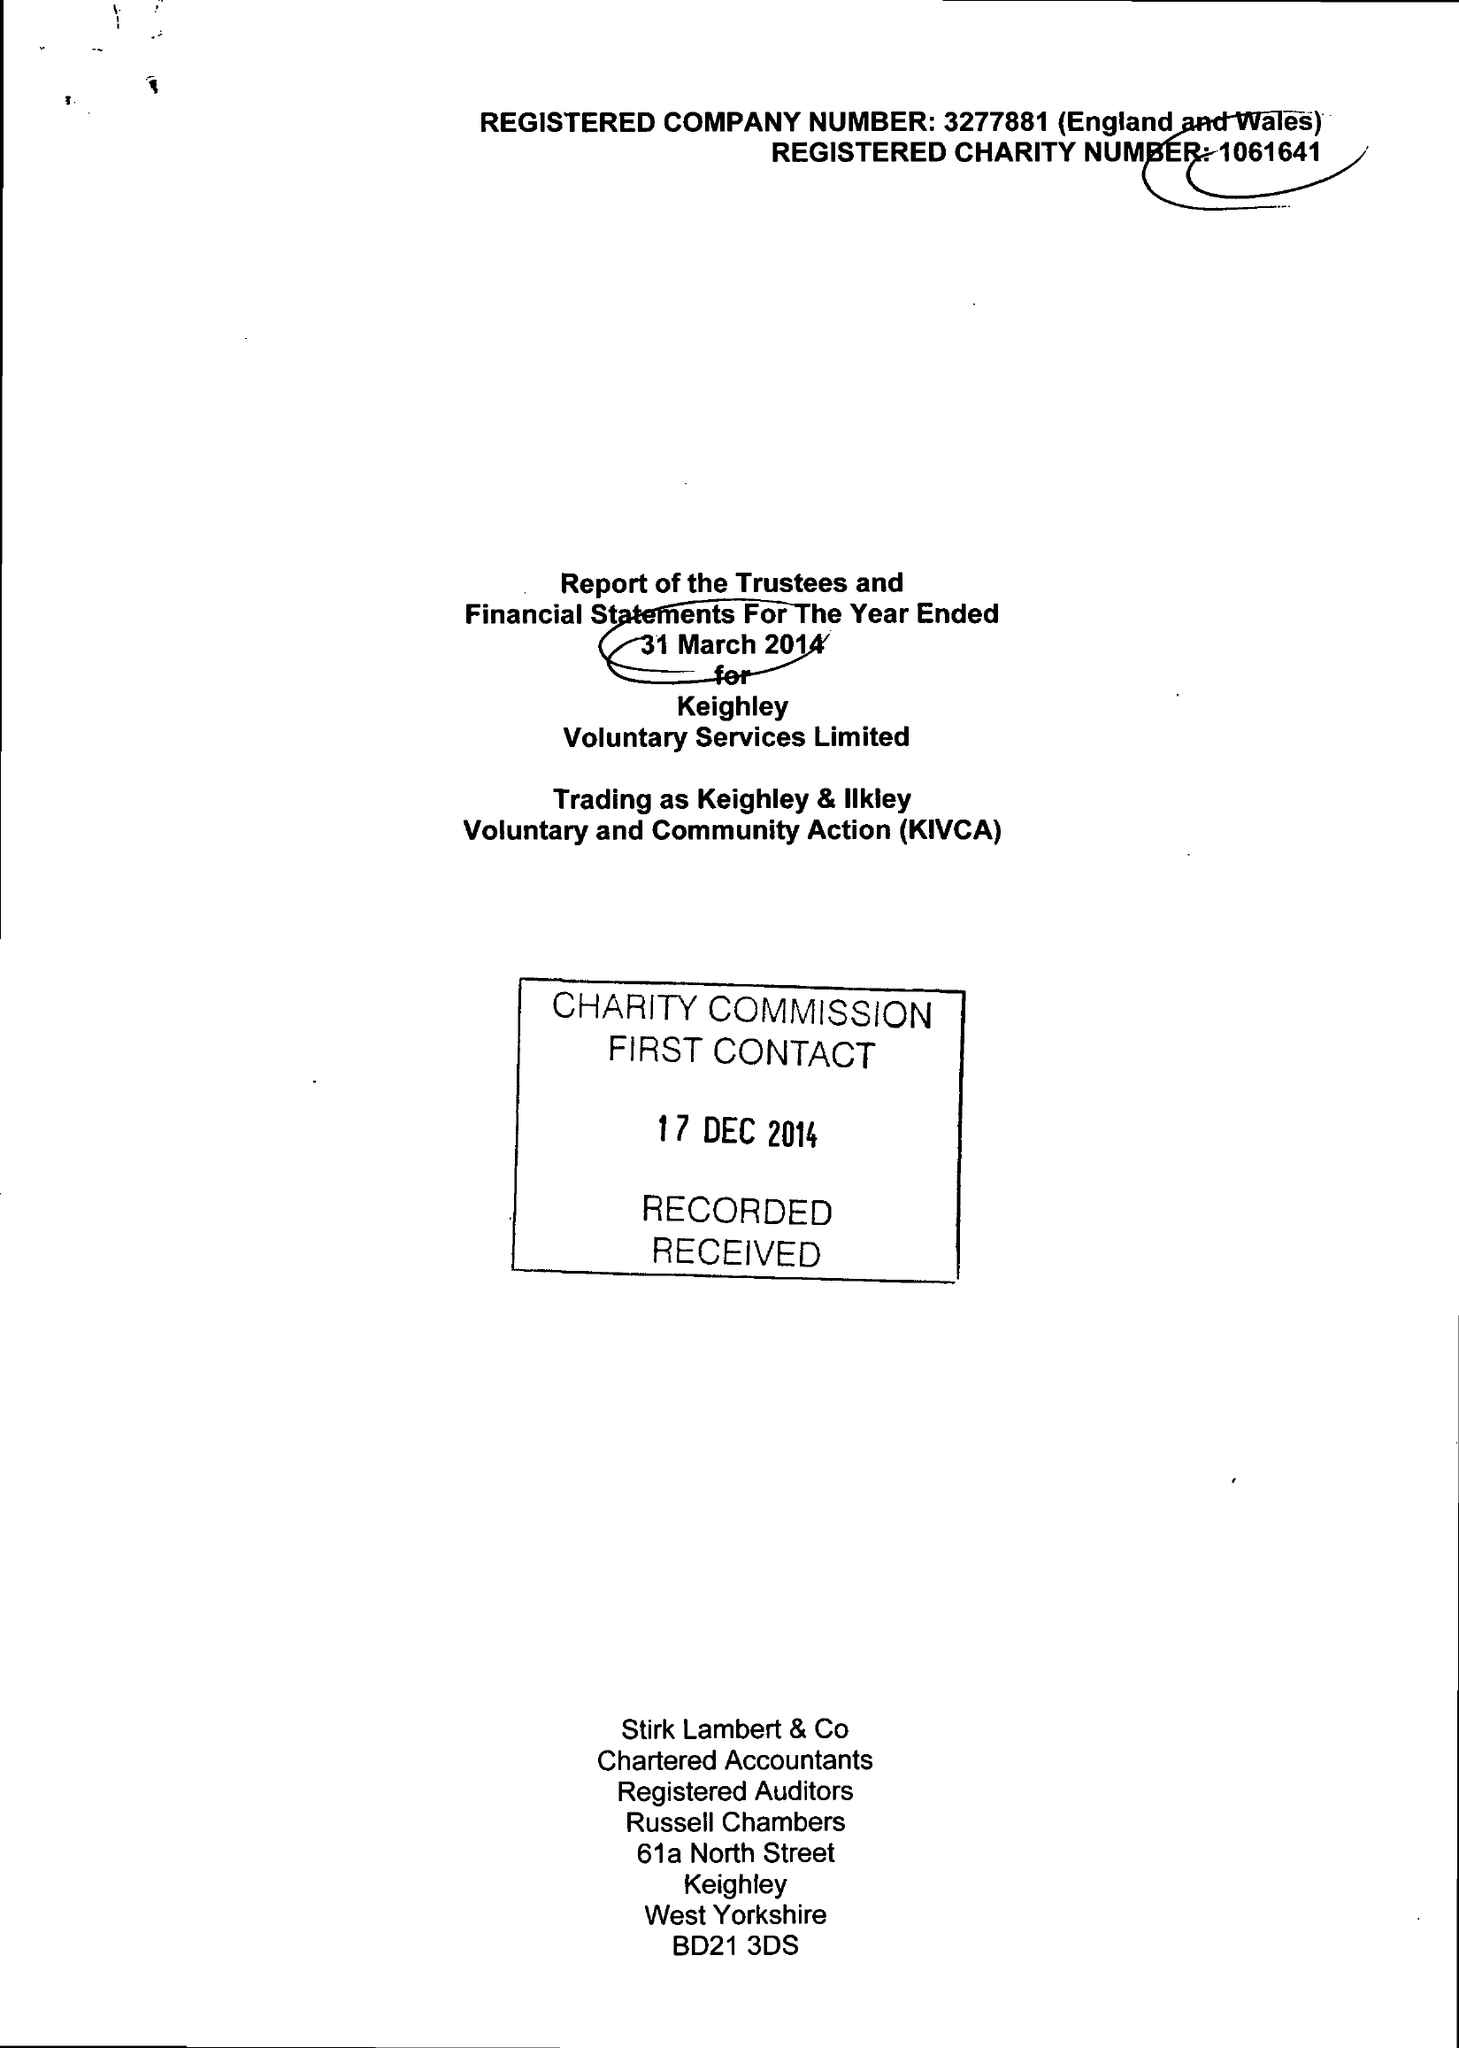What is the value for the spending_annually_in_british_pounds?
Answer the question using a single word or phrase. 989533.00 